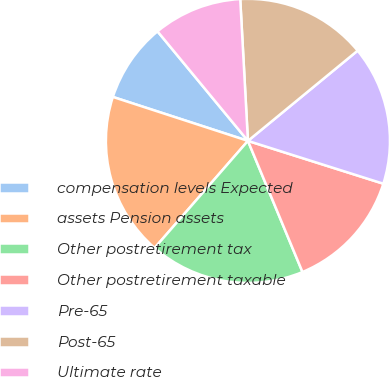Convert chart. <chart><loc_0><loc_0><loc_500><loc_500><pie_chart><fcel>compensation levels Expected<fcel>assets Pension assets<fcel>Other postretirement tax<fcel>Other postretirement taxable<fcel>Pre-65<fcel>Post-65<fcel>Ultimate rate<nl><fcel>9.01%<fcel>18.6%<fcel>17.68%<fcel>13.85%<fcel>15.83%<fcel>14.91%<fcel>10.12%<nl></chart> 